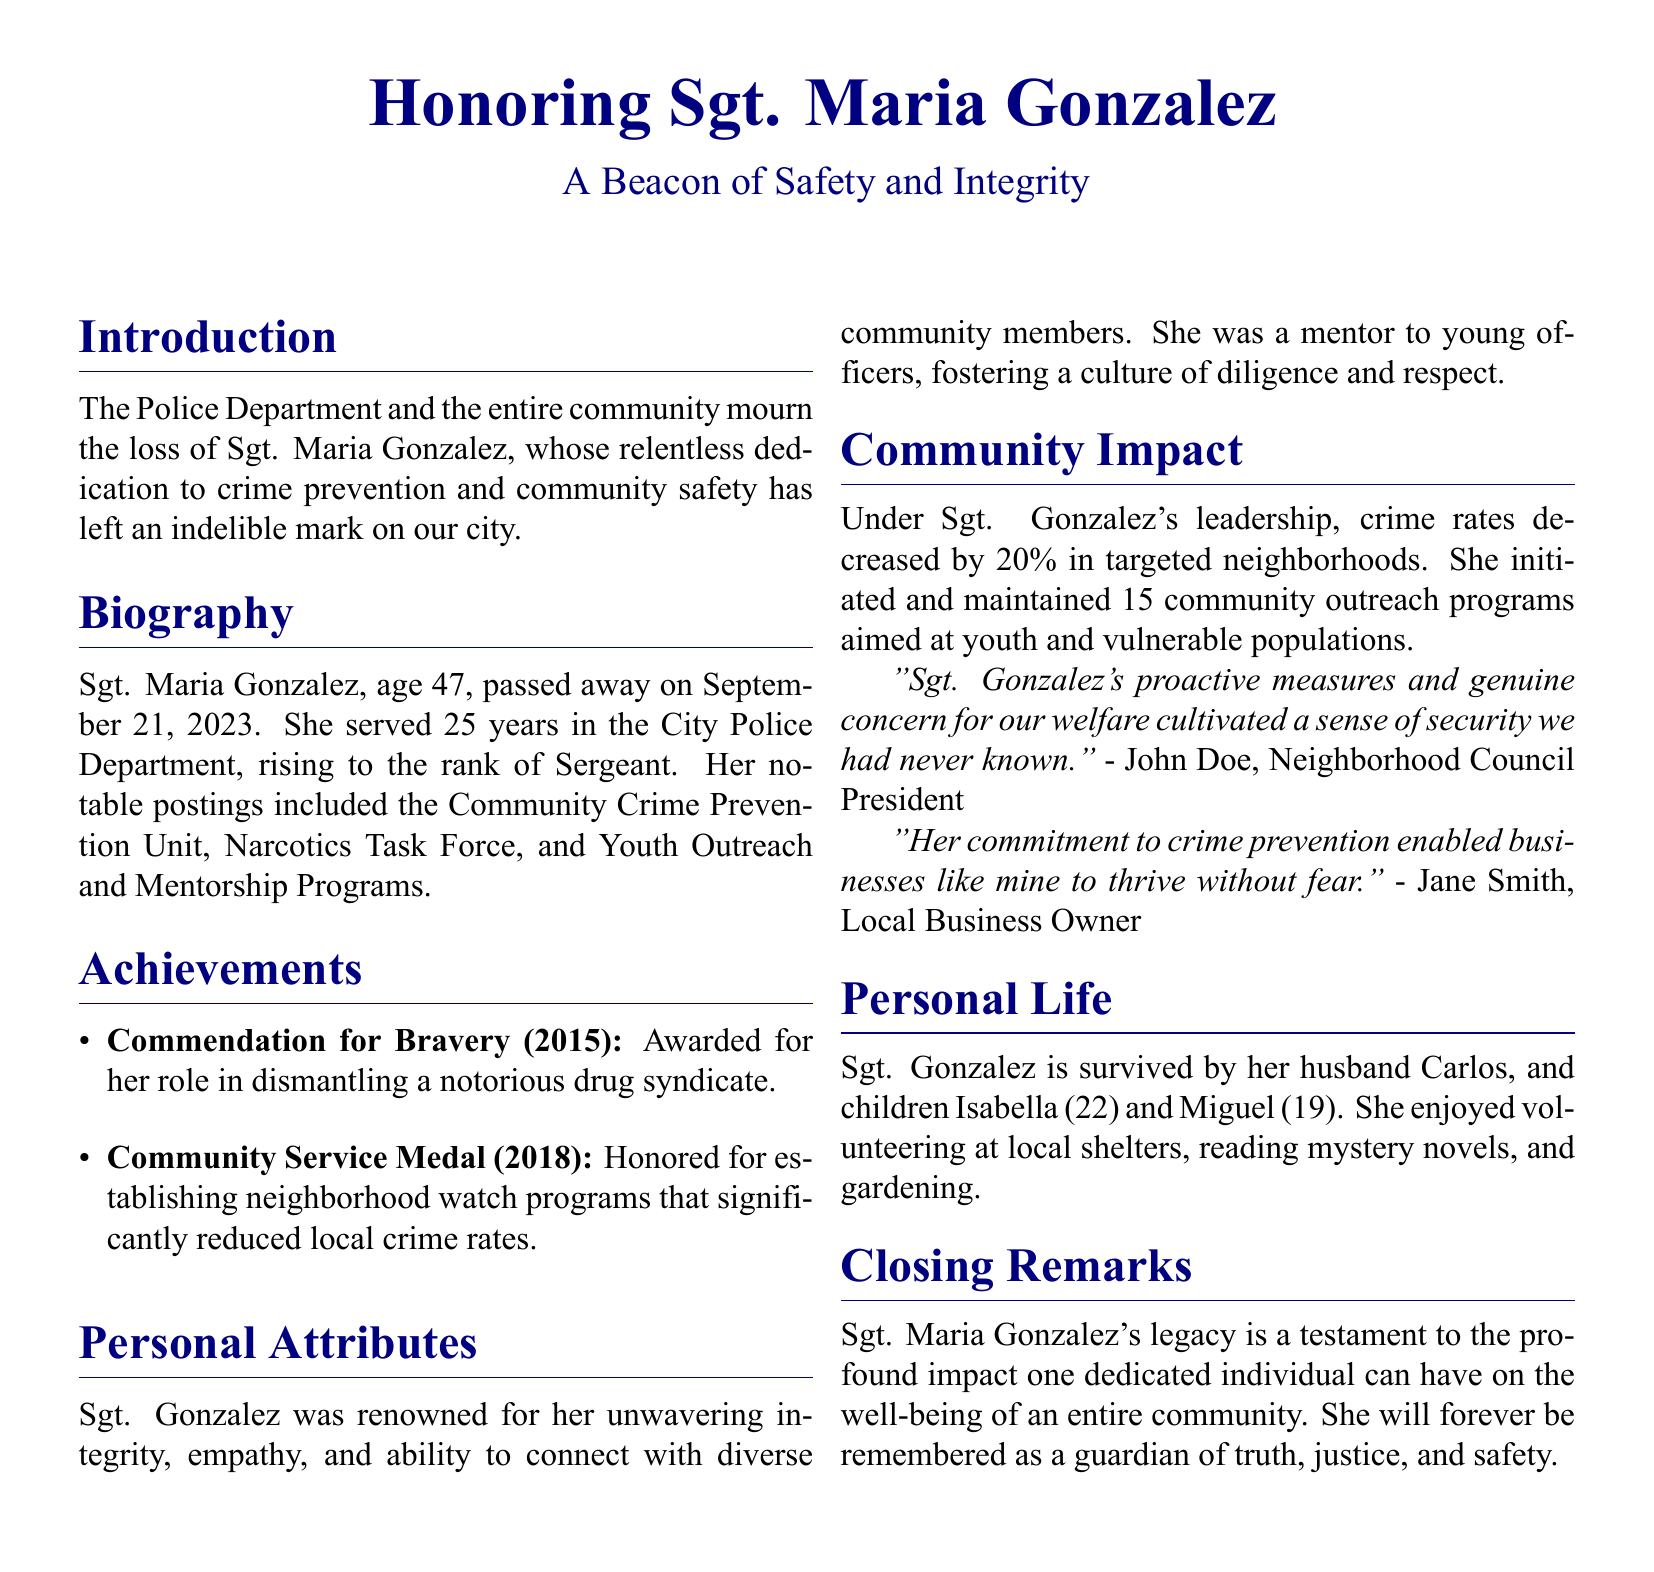what was Sgt. Maria Gonzalez's age at passing? Sgt. Maria Gonzalez was 47 years old when she passed away on September 21, 2023.
Answer: 47 when did Sgt. Maria Gonzalez pass away? The document states she passed away on September 21, 2023.
Answer: September 21, 2023 how many years did she serve in the Police Department? The text mentions she served 25 years in the City Police Department.
Answer: 25 years which prestigious award did she receive in 2015? The document highlights that she received the Commendation for Bravery in 2015.
Answer: Commendation for Bravery what percentage did crime rates decrease under her leadership? The document notes that crime rates decreased by 20% in targeted neighborhoods.
Answer: 20% who did Sgt. Gonzalez mentor? She was a mentor to young officers, according to the document.
Answer: young officers what was one of her roles in the police department? The document lists her role in the Community Crime Prevention Unit.
Answer: Community Crime Prevention Unit how many community outreach programs did she initiate? The document states that she initiated and maintained 15 community outreach programs.
Answer: 15 who is quoted as saying her measures cultivated a sense of security? John Doe, Neighborhood Council President is quoted in the document.
Answer: John Doe what is the main theme of the closing remarks? The closing remarks emphasize her profound impact on the community’s well-being.
Answer: profound impact on the community’s well-being 